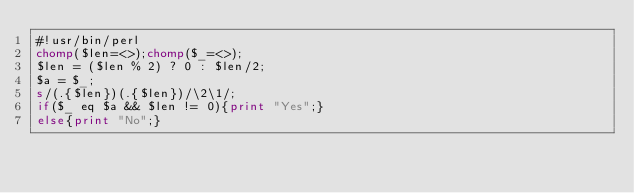<code> <loc_0><loc_0><loc_500><loc_500><_Perl_>#!usr/bin/perl
chomp($len=<>);chomp($_=<>);
$len = ($len % 2) ? 0 : $len/2;
$a = $_;
s/(.{$len})(.{$len})/\2\1/;
if($_ eq $a && $len != 0){print "Yes";}
else{print "No";}</code> 